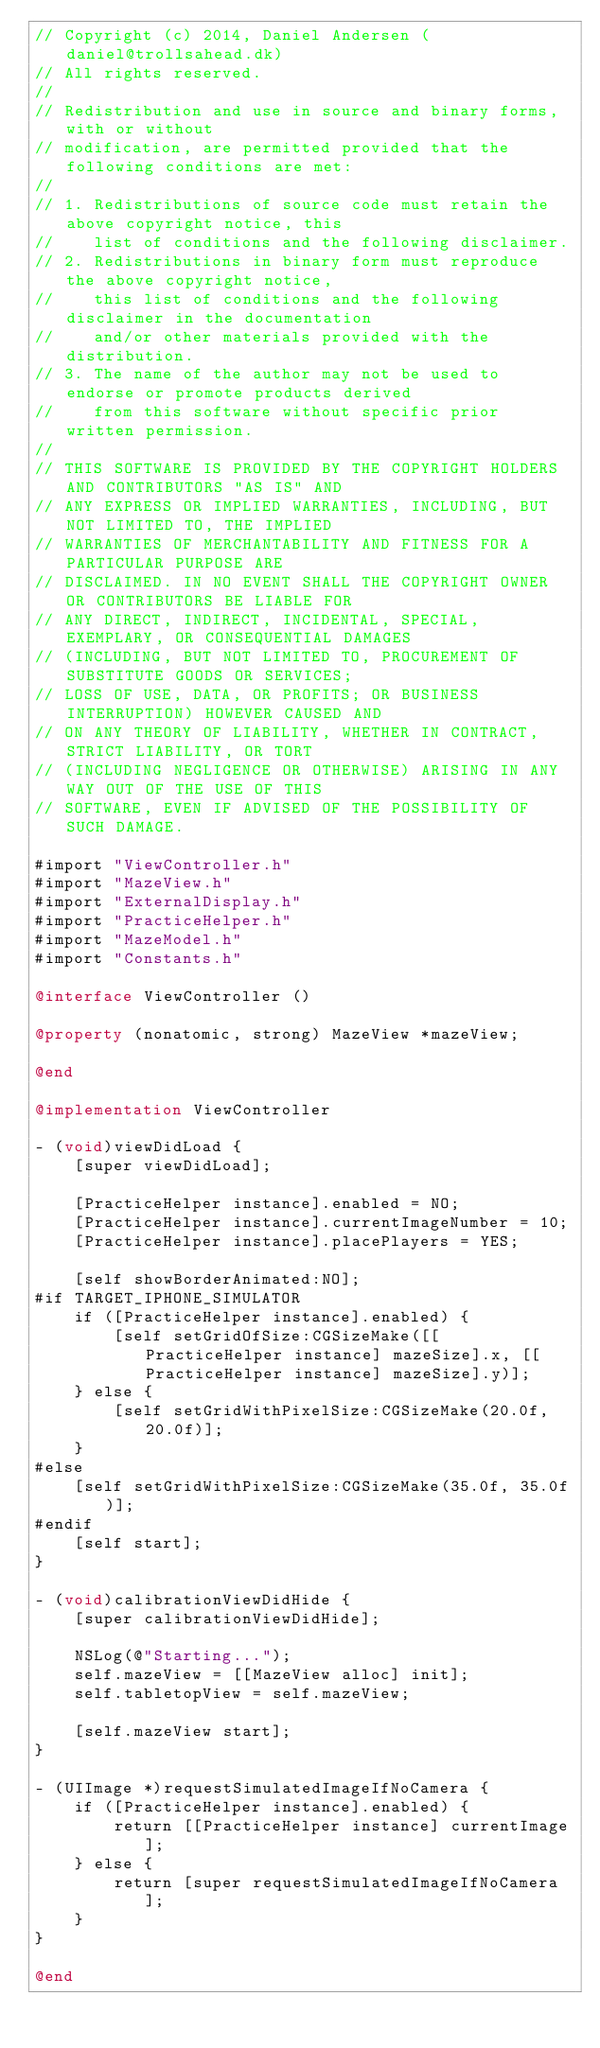<code> <loc_0><loc_0><loc_500><loc_500><_ObjectiveC_>// Copyright (c) 2014, Daniel Andersen (daniel@trollsahead.dk)
// All rights reserved.
//
// Redistribution and use in source and binary forms, with or without
// modification, are permitted provided that the following conditions are met:
//
// 1. Redistributions of source code must retain the above copyright notice, this
//    list of conditions and the following disclaimer.
// 2. Redistributions in binary form must reproduce the above copyright notice,
//    this list of conditions and the following disclaimer in the documentation
//    and/or other materials provided with the distribution.
// 3. The name of the author may not be used to endorse or promote products derived
//    from this software without specific prior written permission.
//
// THIS SOFTWARE IS PROVIDED BY THE COPYRIGHT HOLDERS AND CONTRIBUTORS "AS IS" AND
// ANY EXPRESS OR IMPLIED WARRANTIES, INCLUDING, BUT NOT LIMITED TO, THE IMPLIED
// WARRANTIES OF MERCHANTABILITY AND FITNESS FOR A PARTICULAR PURPOSE ARE
// DISCLAIMED. IN NO EVENT SHALL THE COPYRIGHT OWNER OR CONTRIBUTORS BE LIABLE FOR
// ANY DIRECT, INDIRECT, INCIDENTAL, SPECIAL, EXEMPLARY, OR CONSEQUENTIAL DAMAGES
// (INCLUDING, BUT NOT LIMITED TO, PROCUREMENT OF SUBSTITUTE GOODS OR SERVICES;
// LOSS OF USE, DATA, OR PROFITS; OR BUSINESS INTERRUPTION) HOWEVER CAUSED AND
// ON ANY THEORY OF LIABILITY, WHETHER IN CONTRACT, STRICT LIABILITY, OR TORT
// (INCLUDING NEGLIGENCE OR OTHERWISE) ARISING IN ANY WAY OUT OF THE USE OF THIS
// SOFTWARE, EVEN IF ADVISED OF THE POSSIBILITY OF SUCH DAMAGE.

#import "ViewController.h"
#import "MazeView.h"
#import "ExternalDisplay.h"
#import "PracticeHelper.h"
#import "MazeModel.h"
#import "Constants.h"

@interface ViewController ()

@property (nonatomic, strong) MazeView *mazeView;

@end

@implementation ViewController

- (void)viewDidLoad {
    [super viewDidLoad];

    [PracticeHelper instance].enabled = NO;
    [PracticeHelper instance].currentImageNumber = 10;
    [PracticeHelper instance].placePlayers = YES;
    
    [self showBorderAnimated:NO];
#if TARGET_IPHONE_SIMULATOR
    if ([PracticeHelper instance].enabled) {
        [self setGridOfSize:CGSizeMake([[PracticeHelper instance] mazeSize].x, [[PracticeHelper instance] mazeSize].y)];
    } else {
        [self setGridWithPixelSize:CGSizeMake(20.0f, 20.0f)];
    }
#else
    [self setGridWithPixelSize:CGSizeMake(35.0f, 35.0f)];
#endif
    [self start];
}

- (void)calibrationViewDidHide {
    [super calibrationViewDidHide];

    NSLog(@"Starting...");
    self.mazeView = [[MazeView alloc] init];
    self.tabletopView = self.mazeView;

    [self.mazeView start];
}

- (UIImage *)requestSimulatedImageIfNoCamera {
    if ([PracticeHelper instance].enabled) {
        return [[PracticeHelper instance] currentImage];
    } else {
        return [super requestSimulatedImageIfNoCamera];
    }
}

@end
</code> 